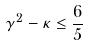<formula> <loc_0><loc_0><loc_500><loc_500>\gamma ^ { 2 } - \kappa \leq \frac { 6 } { 5 }</formula> 